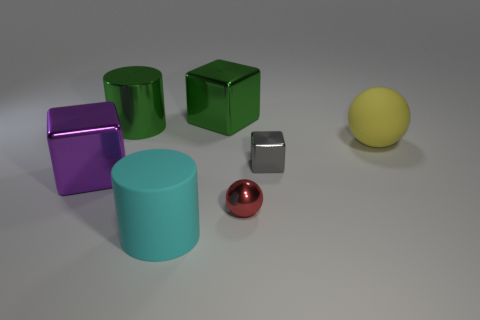There is a red thing; does it have the same size as the gray thing behind the large cyan object?
Ensure brevity in your answer.  Yes. How big is the cylinder that is in front of the large cylinder left of the big rubber object that is on the left side of the yellow ball?
Provide a succinct answer. Large. Are there any large purple rubber cubes?
Your answer should be compact. No. What number of large things have the same color as the big shiny cylinder?
Your response must be concise. 1. How many objects are big things to the left of the large green metallic cylinder or shiny objects in front of the purple thing?
Ensure brevity in your answer.  2. There is a big matte object that is left of the red metal thing; what number of big green metallic things are on the right side of it?
Make the answer very short. 1. What color is the object that is made of the same material as the large ball?
Give a very brief answer. Cyan. Are there any yellow objects that have the same size as the gray metallic object?
Your response must be concise. No. There is a purple thing that is the same size as the yellow ball; what is its shape?
Make the answer very short. Cube. Is there another thing of the same shape as the big yellow matte thing?
Your response must be concise. Yes. 